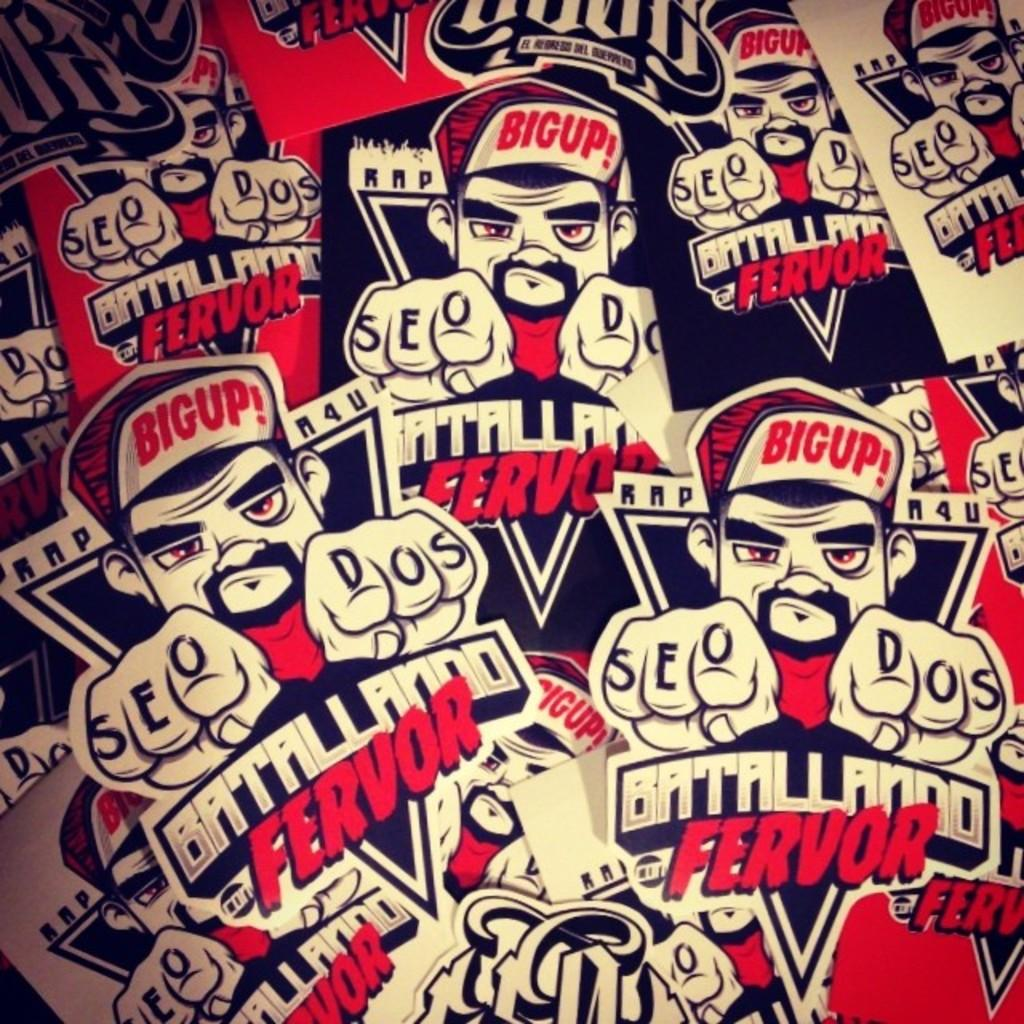Provide a one-sentence caption for the provided image. A man with a cap that reads Big, with both index fingers pointed forward, appears repeatedly alongside words Battalliando Fervor. 